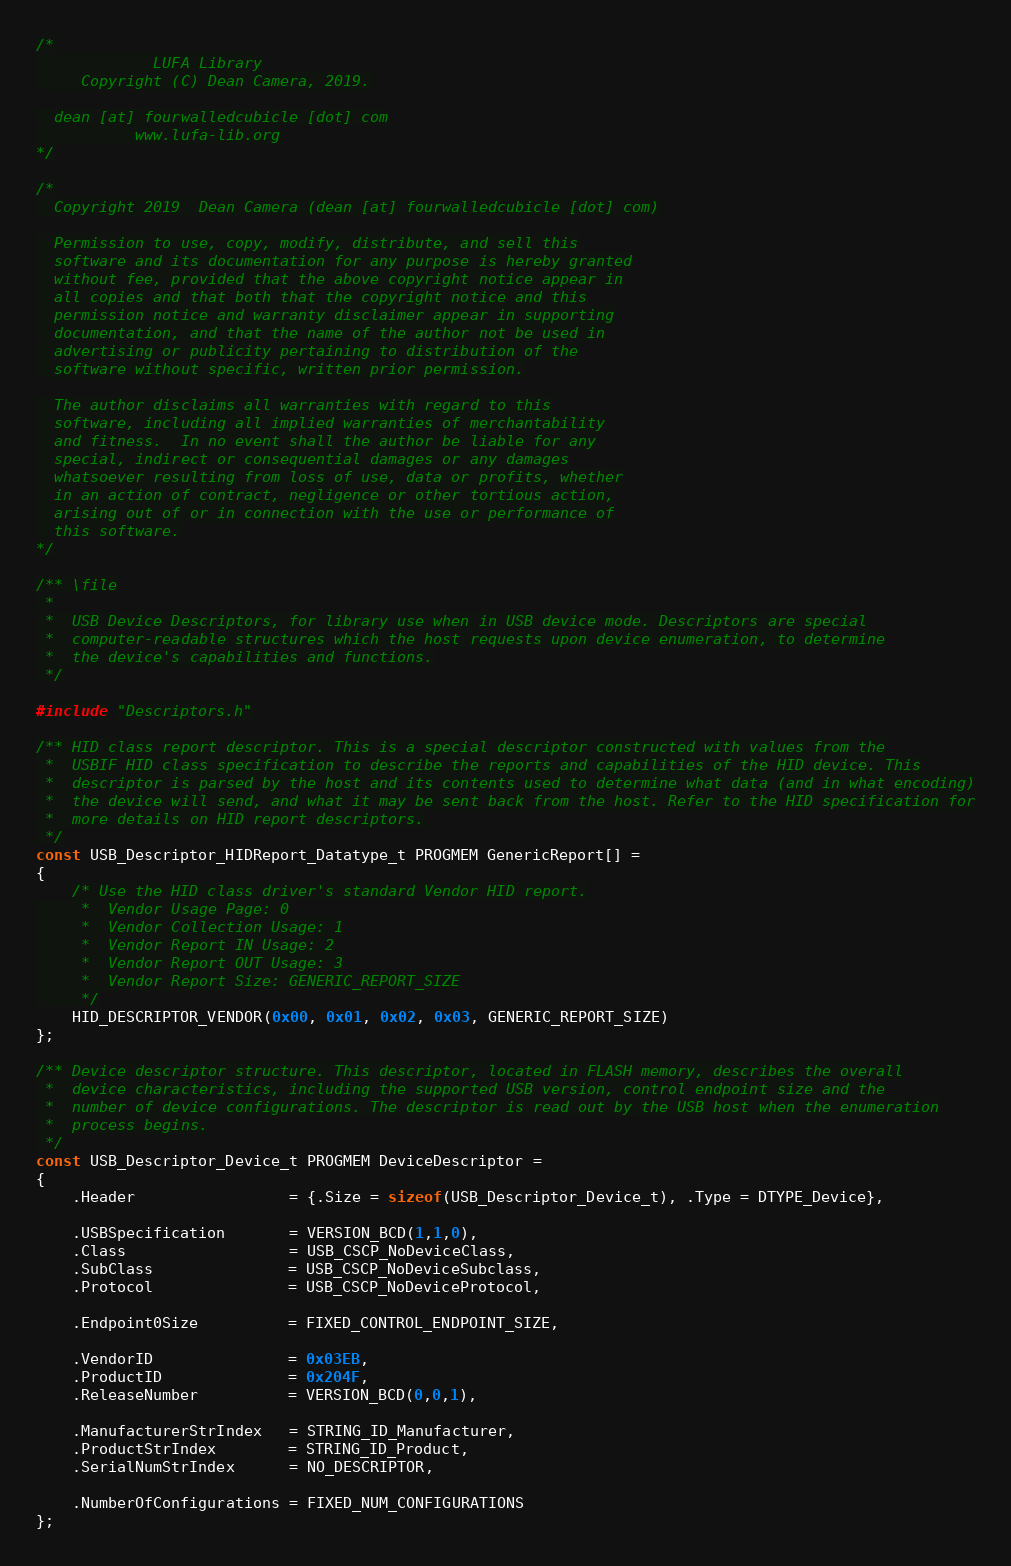<code> <loc_0><loc_0><loc_500><loc_500><_C_>/*
             LUFA Library
     Copyright (C) Dean Camera, 2019.

  dean [at] fourwalledcubicle [dot] com
           www.lufa-lib.org
*/

/*
  Copyright 2019  Dean Camera (dean [at] fourwalledcubicle [dot] com)

  Permission to use, copy, modify, distribute, and sell this
  software and its documentation for any purpose is hereby granted
  without fee, provided that the above copyright notice appear in
  all copies and that both that the copyright notice and this
  permission notice and warranty disclaimer appear in supporting
  documentation, and that the name of the author not be used in
  advertising or publicity pertaining to distribution of the
  software without specific, written prior permission.

  The author disclaims all warranties with regard to this
  software, including all implied warranties of merchantability
  and fitness.  In no event shall the author be liable for any
  special, indirect or consequential damages or any damages
  whatsoever resulting from loss of use, data or profits, whether
  in an action of contract, negligence or other tortious action,
  arising out of or in connection with the use or performance of
  this software.
*/

/** \file
 *
 *  USB Device Descriptors, for library use when in USB device mode. Descriptors are special
 *  computer-readable structures which the host requests upon device enumeration, to determine
 *  the device's capabilities and functions.
 */

#include "Descriptors.h"

/** HID class report descriptor. This is a special descriptor constructed with values from the
 *  USBIF HID class specification to describe the reports and capabilities of the HID device. This
 *  descriptor is parsed by the host and its contents used to determine what data (and in what encoding)
 *  the device will send, and what it may be sent back from the host. Refer to the HID specification for
 *  more details on HID report descriptors.
 */
const USB_Descriptor_HIDReport_Datatype_t PROGMEM GenericReport[] =
{
	/* Use the HID class driver's standard Vendor HID report.
	 *  Vendor Usage Page: 0
	 *  Vendor Collection Usage: 1
	 *  Vendor Report IN Usage: 2
	 *  Vendor Report OUT Usage: 3
	 *  Vendor Report Size: GENERIC_REPORT_SIZE
	 */
	HID_DESCRIPTOR_VENDOR(0x00, 0x01, 0x02, 0x03, GENERIC_REPORT_SIZE)
};

/** Device descriptor structure. This descriptor, located in FLASH memory, describes the overall
 *  device characteristics, including the supported USB version, control endpoint size and the
 *  number of device configurations. The descriptor is read out by the USB host when the enumeration
 *  process begins.
 */
const USB_Descriptor_Device_t PROGMEM DeviceDescriptor =
{
	.Header                 = {.Size = sizeof(USB_Descriptor_Device_t), .Type = DTYPE_Device},

	.USBSpecification       = VERSION_BCD(1,1,0),
	.Class                  = USB_CSCP_NoDeviceClass,
	.SubClass               = USB_CSCP_NoDeviceSubclass,
	.Protocol               = USB_CSCP_NoDeviceProtocol,

	.Endpoint0Size          = FIXED_CONTROL_ENDPOINT_SIZE,

	.VendorID               = 0x03EB,
	.ProductID              = 0x204F,
	.ReleaseNumber          = VERSION_BCD(0,0,1),

	.ManufacturerStrIndex   = STRING_ID_Manufacturer,
	.ProductStrIndex        = STRING_ID_Product,
	.SerialNumStrIndex      = NO_DESCRIPTOR,

	.NumberOfConfigurations = FIXED_NUM_CONFIGURATIONS
};
</code> 